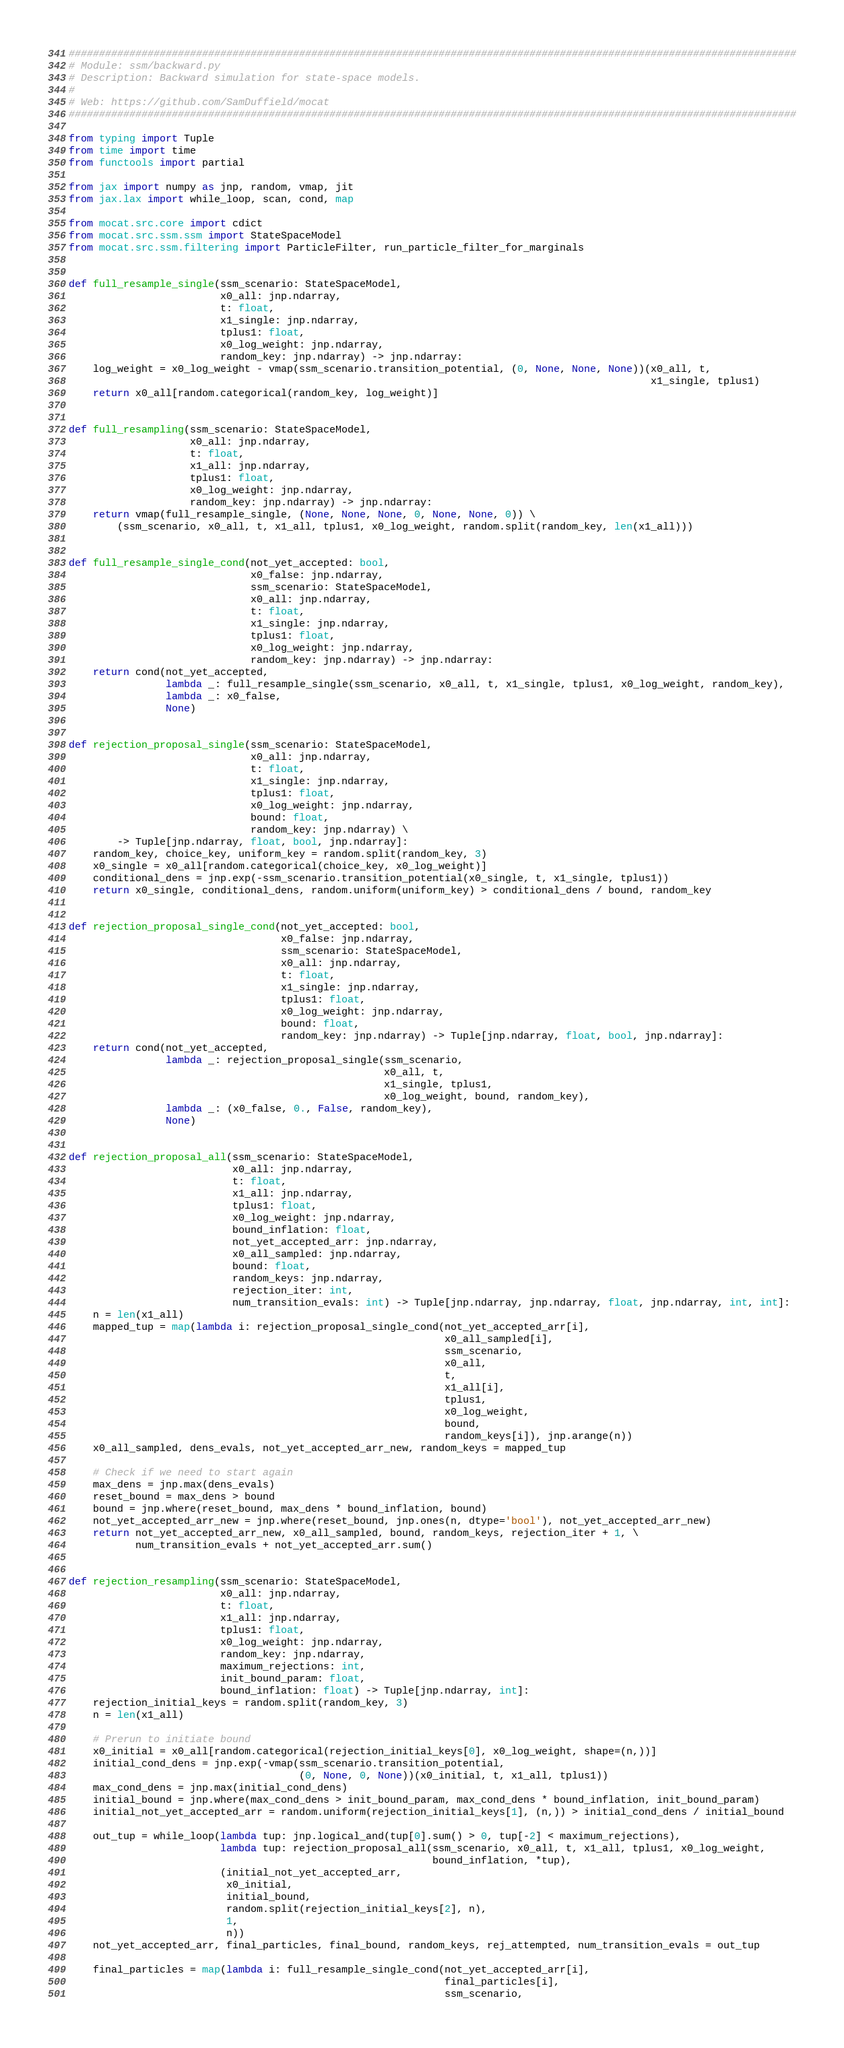Convert code to text. <code><loc_0><loc_0><loc_500><loc_500><_Python_>########################################################################################################################
# Module: ssm/backward.py
# Description: Backward simulation for state-space models.
#
# Web: https://github.com/SamDuffield/mocat
########################################################################################################################

from typing import Tuple
from time import time
from functools import partial

from jax import numpy as jnp, random, vmap, jit
from jax.lax import while_loop, scan, cond, map

from mocat.src.core import cdict
from mocat.src.ssm.ssm import StateSpaceModel
from mocat.src.ssm.filtering import ParticleFilter, run_particle_filter_for_marginals


def full_resample_single(ssm_scenario: StateSpaceModel,
                         x0_all: jnp.ndarray,
                         t: float,
                         x1_single: jnp.ndarray,
                         tplus1: float,
                         x0_log_weight: jnp.ndarray,
                         random_key: jnp.ndarray) -> jnp.ndarray:
    log_weight = x0_log_weight - vmap(ssm_scenario.transition_potential, (0, None, None, None))(x0_all, t,
                                                                                                x1_single, tplus1)
    return x0_all[random.categorical(random_key, log_weight)]


def full_resampling(ssm_scenario: StateSpaceModel,
                    x0_all: jnp.ndarray,
                    t: float,
                    x1_all: jnp.ndarray,
                    tplus1: float,
                    x0_log_weight: jnp.ndarray,
                    random_key: jnp.ndarray) -> jnp.ndarray:
    return vmap(full_resample_single, (None, None, None, 0, None, None, 0)) \
        (ssm_scenario, x0_all, t, x1_all, tplus1, x0_log_weight, random.split(random_key, len(x1_all)))


def full_resample_single_cond(not_yet_accepted: bool,
                              x0_false: jnp.ndarray,
                              ssm_scenario: StateSpaceModel,
                              x0_all: jnp.ndarray,
                              t: float,
                              x1_single: jnp.ndarray,
                              tplus1: float,
                              x0_log_weight: jnp.ndarray,
                              random_key: jnp.ndarray) -> jnp.ndarray:
    return cond(not_yet_accepted,
                lambda _: full_resample_single(ssm_scenario, x0_all, t, x1_single, tplus1, x0_log_weight, random_key),
                lambda _: x0_false,
                None)


def rejection_proposal_single(ssm_scenario: StateSpaceModel,
                              x0_all: jnp.ndarray,
                              t: float,
                              x1_single: jnp.ndarray,
                              tplus1: float,
                              x0_log_weight: jnp.ndarray,
                              bound: float,
                              random_key: jnp.ndarray) \
        -> Tuple[jnp.ndarray, float, bool, jnp.ndarray]:
    random_key, choice_key, uniform_key = random.split(random_key, 3)
    x0_single = x0_all[random.categorical(choice_key, x0_log_weight)]
    conditional_dens = jnp.exp(-ssm_scenario.transition_potential(x0_single, t, x1_single, tplus1))
    return x0_single, conditional_dens, random.uniform(uniform_key) > conditional_dens / bound, random_key


def rejection_proposal_single_cond(not_yet_accepted: bool,
                                   x0_false: jnp.ndarray,
                                   ssm_scenario: StateSpaceModel,
                                   x0_all: jnp.ndarray,
                                   t: float,
                                   x1_single: jnp.ndarray,
                                   tplus1: float,
                                   x0_log_weight: jnp.ndarray,
                                   bound: float,
                                   random_key: jnp.ndarray) -> Tuple[jnp.ndarray, float, bool, jnp.ndarray]:
    return cond(not_yet_accepted,
                lambda _: rejection_proposal_single(ssm_scenario,
                                                    x0_all, t,
                                                    x1_single, tplus1,
                                                    x0_log_weight, bound, random_key),
                lambda _: (x0_false, 0., False, random_key),
                None)


def rejection_proposal_all(ssm_scenario: StateSpaceModel,
                           x0_all: jnp.ndarray,
                           t: float,
                           x1_all: jnp.ndarray,
                           tplus1: float,
                           x0_log_weight: jnp.ndarray,
                           bound_inflation: float,
                           not_yet_accepted_arr: jnp.ndarray,
                           x0_all_sampled: jnp.ndarray,
                           bound: float,
                           random_keys: jnp.ndarray,
                           rejection_iter: int,
                           num_transition_evals: int) -> Tuple[jnp.ndarray, jnp.ndarray, float, jnp.ndarray, int, int]:
    n = len(x1_all)
    mapped_tup = map(lambda i: rejection_proposal_single_cond(not_yet_accepted_arr[i],
                                                              x0_all_sampled[i],
                                                              ssm_scenario,
                                                              x0_all,
                                                              t,
                                                              x1_all[i],
                                                              tplus1,
                                                              x0_log_weight,
                                                              bound,
                                                              random_keys[i]), jnp.arange(n))
    x0_all_sampled, dens_evals, not_yet_accepted_arr_new, random_keys = mapped_tup

    # Check if we need to start again
    max_dens = jnp.max(dens_evals)
    reset_bound = max_dens > bound
    bound = jnp.where(reset_bound, max_dens * bound_inflation, bound)
    not_yet_accepted_arr_new = jnp.where(reset_bound, jnp.ones(n, dtype='bool'), not_yet_accepted_arr_new)
    return not_yet_accepted_arr_new, x0_all_sampled, bound, random_keys, rejection_iter + 1, \
           num_transition_evals + not_yet_accepted_arr.sum()


def rejection_resampling(ssm_scenario: StateSpaceModel,
                         x0_all: jnp.ndarray,
                         t: float,
                         x1_all: jnp.ndarray,
                         tplus1: float,
                         x0_log_weight: jnp.ndarray,
                         random_key: jnp.ndarray,
                         maximum_rejections: int,
                         init_bound_param: float,
                         bound_inflation: float) -> Tuple[jnp.ndarray, int]:
    rejection_initial_keys = random.split(random_key, 3)
    n = len(x1_all)

    # Prerun to initiate bound
    x0_initial = x0_all[random.categorical(rejection_initial_keys[0], x0_log_weight, shape=(n,))]
    initial_cond_dens = jnp.exp(-vmap(ssm_scenario.transition_potential,
                                      (0, None, 0, None))(x0_initial, t, x1_all, tplus1))
    max_cond_dens = jnp.max(initial_cond_dens)
    initial_bound = jnp.where(max_cond_dens > init_bound_param, max_cond_dens * bound_inflation, init_bound_param)
    initial_not_yet_accepted_arr = random.uniform(rejection_initial_keys[1], (n,)) > initial_cond_dens / initial_bound

    out_tup = while_loop(lambda tup: jnp.logical_and(tup[0].sum() > 0, tup[-2] < maximum_rejections),
                         lambda tup: rejection_proposal_all(ssm_scenario, x0_all, t, x1_all, tplus1, x0_log_weight,
                                                            bound_inflation, *tup),
                         (initial_not_yet_accepted_arr,
                          x0_initial,
                          initial_bound,
                          random.split(rejection_initial_keys[2], n),
                          1,
                          n))
    not_yet_accepted_arr, final_particles, final_bound, random_keys, rej_attempted, num_transition_evals = out_tup

    final_particles = map(lambda i: full_resample_single_cond(not_yet_accepted_arr[i],
                                                              final_particles[i],
                                                              ssm_scenario,</code> 